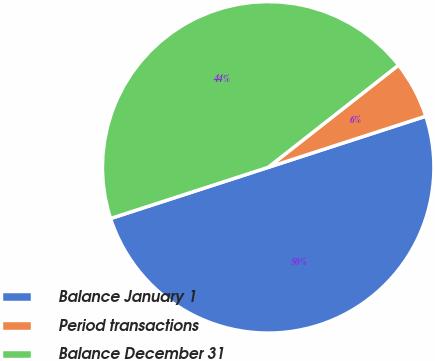Convert chart. <chart><loc_0><loc_0><loc_500><loc_500><pie_chart><fcel>Balance January 1<fcel>Period transactions<fcel>Balance December 31<nl><fcel>50.0%<fcel>5.59%<fcel>44.41%<nl></chart> 